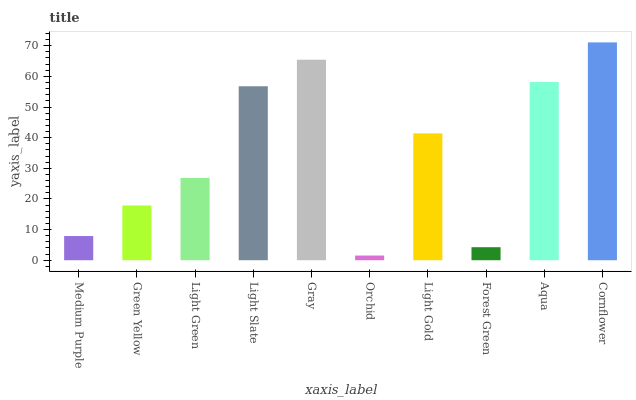Is Orchid the minimum?
Answer yes or no. Yes. Is Cornflower the maximum?
Answer yes or no. Yes. Is Green Yellow the minimum?
Answer yes or no. No. Is Green Yellow the maximum?
Answer yes or no. No. Is Green Yellow greater than Medium Purple?
Answer yes or no. Yes. Is Medium Purple less than Green Yellow?
Answer yes or no. Yes. Is Medium Purple greater than Green Yellow?
Answer yes or no. No. Is Green Yellow less than Medium Purple?
Answer yes or no. No. Is Light Gold the high median?
Answer yes or no. Yes. Is Light Green the low median?
Answer yes or no. Yes. Is Light Green the high median?
Answer yes or no. No. Is Medium Purple the low median?
Answer yes or no. No. 